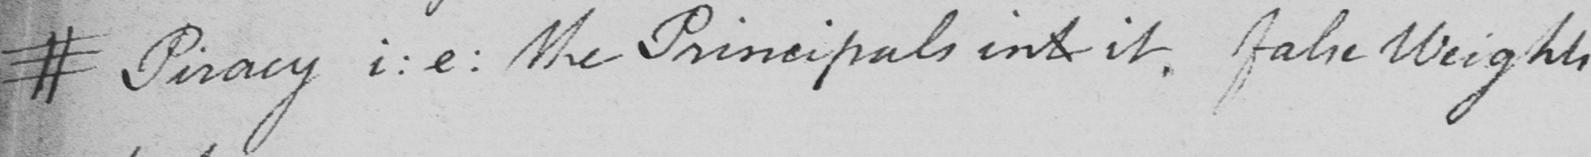Transcribe the text shown in this historical manuscript line. # Piracy i : e :  the Principals int it . False Weights 